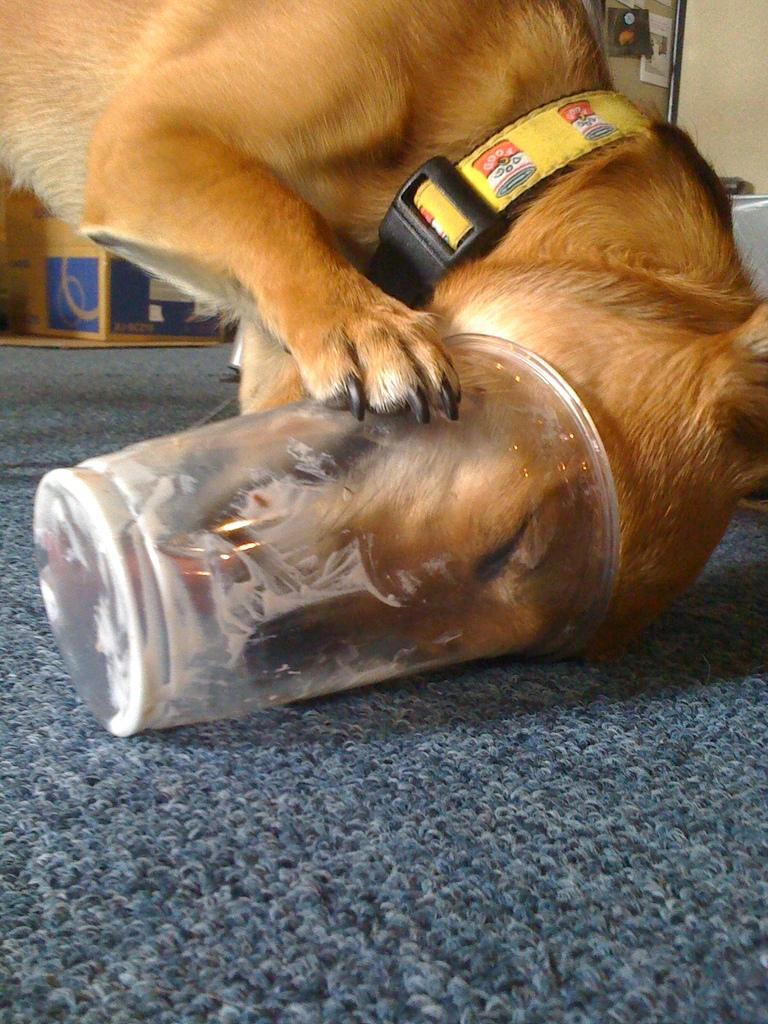What animal can be seen in the image? There is a dog in the image. Where is the dog positioned in the image? The dog is standing on a mat. What object in the image has a dog's face? There is an object with a dog's face in the image. What can be seen in the background of the image? There are boxes and other objects in the background of the image. What type of voice does the dog have in the image? The image is a still photograph, so there is no sound or voice present. 